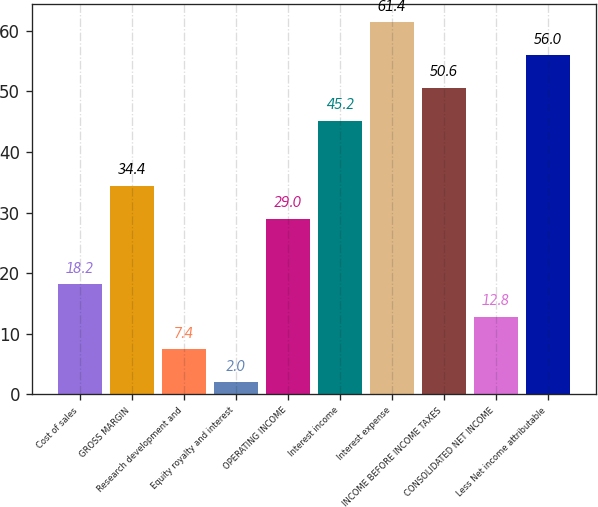Convert chart. <chart><loc_0><loc_0><loc_500><loc_500><bar_chart><fcel>Cost of sales<fcel>GROSS MARGIN<fcel>Research development and<fcel>Equity royalty and interest<fcel>OPERATING INCOME<fcel>Interest income<fcel>Interest expense<fcel>INCOME BEFORE INCOME TAXES<fcel>CONSOLIDATED NET INCOME<fcel>Less Net income attributable<nl><fcel>18.2<fcel>34.4<fcel>7.4<fcel>2<fcel>29<fcel>45.2<fcel>61.4<fcel>50.6<fcel>12.8<fcel>56<nl></chart> 